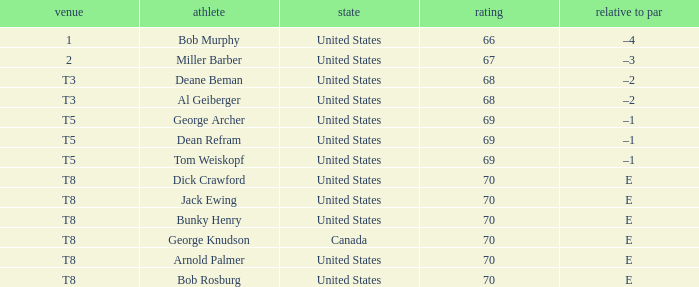When Bunky Henry of the United States scored higher than 68 and his To par was e, what was his place? T8. Parse the full table. {'header': ['venue', 'athlete', 'state', 'rating', 'relative to par'], 'rows': [['1', 'Bob Murphy', 'United States', '66', '–4'], ['2', 'Miller Barber', 'United States', '67', '–3'], ['T3', 'Deane Beman', 'United States', '68', '–2'], ['T3', 'Al Geiberger', 'United States', '68', '–2'], ['T5', 'George Archer', 'United States', '69', '–1'], ['T5', 'Dean Refram', 'United States', '69', '–1'], ['T5', 'Tom Weiskopf', 'United States', '69', '–1'], ['T8', 'Dick Crawford', 'United States', '70', 'E'], ['T8', 'Jack Ewing', 'United States', '70', 'E'], ['T8', 'Bunky Henry', 'United States', '70', 'E'], ['T8', 'George Knudson', 'Canada', '70', 'E'], ['T8', 'Arnold Palmer', 'United States', '70', 'E'], ['T8', 'Bob Rosburg', 'United States', '70', 'E']]} 